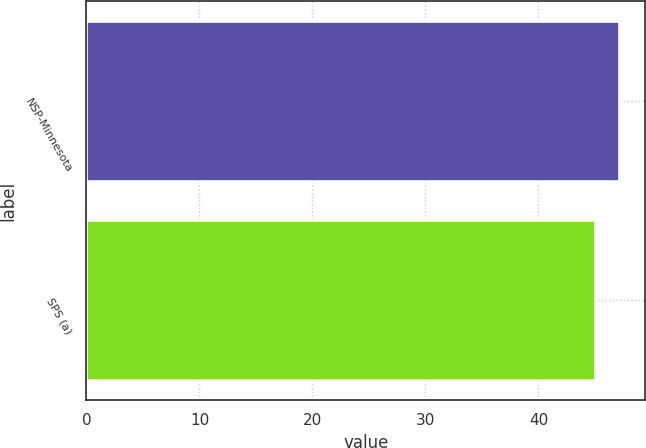Convert chart to OTSL. <chart><loc_0><loc_0><loc_500><loc_500><bar_chart><fcel>NSP-Minnesota<fcel>SPS (a)<nl><fcel>47.1<fcel>45<nl></chart> 